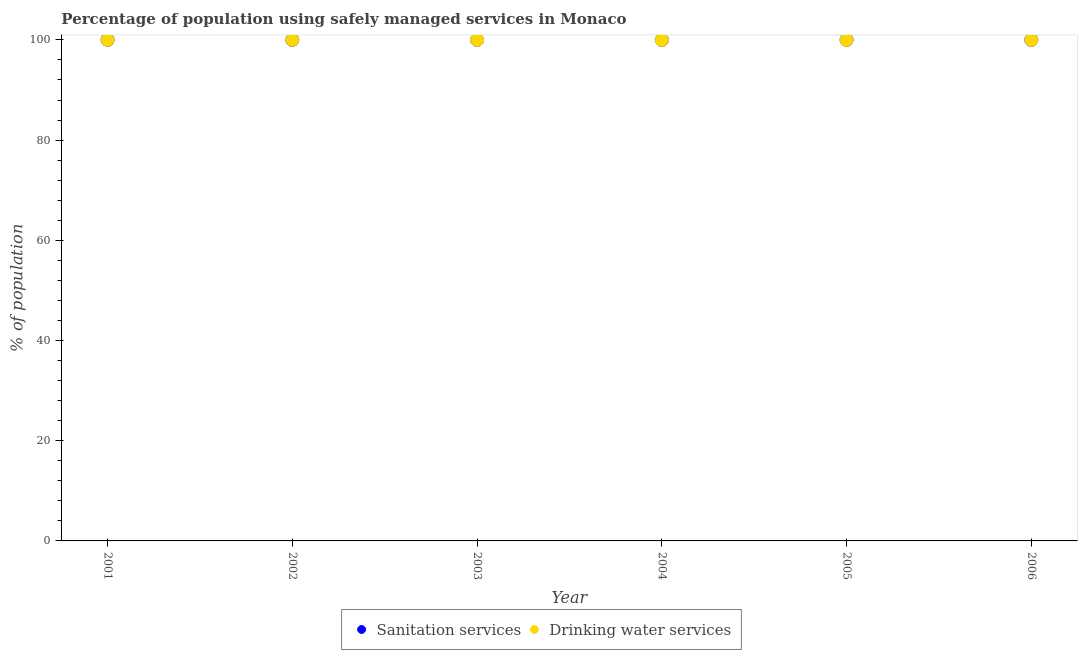How many different coloured dotlines are there?
Make the answer very short. 2. What is the percentage of population who used sanitation services in 2001?
Your answer should be very brief. 100. Across all years, what is the maximum percentage of population who used sanitation services?
Offer a very short reply. 100. Across all years, what is the minimum percentage of population who used sanitation services?
Keep it short and to the point. 100. In which year was the percentage of population who used drinking water services minimum?
Ensure brevity in your answer.  2001. What is the total percentage of population who used sanitation services in the graph?
Your answer should be compact. 600. What is the difference between the percentage of population who used sanitation services in 2001 and that in 2003?
Offer a terse response. 0. What is the average percentage of population who used sanitation services per year?
Give a very brief answer. 100. In how many years, is the percentage of population who used drinking water services greater than 12 %?
Give a very brief answer. 6. What is the ratio of the percentage of population who used sanitation services in 2002 to that in 2003?
Ensure brevity in your answer.  1. Is the percentage of population who used drinking water services in 2003 less than that in 2004?
Your answer should be compact. No. What is the difference between the highest and the lowest percentage of population who used sanitation services?
Your answer should be very brief. 0. Is the percentage of population who used sanitation services strictly greater than the percentage of population who used drinking water services over the years?
Provide a succinct answer. No. Is the percentage of population who used sanitation services strictly less than the percentage of population who used drinking water services over the years?
Offer a terse response. No. Are the values on the major ticks of Y-axis written in scientific E-notation?
Ensure brevity in your answer.  No. Does the graph contain any zero values?
Your answer should be very brief. No. Does the graph contain grids?
Your response must be concise. No. How many legend labels are there?
Provide a succinct answer. 2. How are the legend labels stacked?
Offer a terse response. Horizontal. What is the title of the graph?
Offer a terse response. Percentage of population using safely managed services in Monaco. What is the label or title of the X-axis?
Keep it short and to the point. Year. What is the label or title of the Y-axis?
Ensure brevity in your answer.  % of population. What is the % of population of Sanitation services in 2001?
Offer a terse response. 100. What is the % of population of Drinking water services in 2004?
Provide a succinct answer. 100. What is the % of population of Drinking water services in 2005?
Keep it short and to the point. 100. What is the % of population in Sanitation services in 2006?
Ensure brevity in your answer.  100. What is the % of population in Drinking water services in 2006?
Give a very brief answer. 100. What is the total % of population in Sanitation services in the graph?
Offer a very short reply. 600. What is the total % of population in Drinking water services in the graph?
Give a very brief answer. 600. What is the difference between the % of population of Sanitation services in 2001 and that in 2004?
Offer a terse response. 0. What is the difference between the % of population in Sanitation services in 2001 and that in 2005?
Provide a short and direct response. 0. What is the difference between the % of population in Sanitation services in 2001 and that in 2006?
Provide a short and direct response. 0. What is the difference between the % of population of Sanitation services in 2002 and that in 2003?
Offer a terse response. 0. What is the difference between the % of population in Sanitation services in 2002 and that in 2004?
Ensure brevity in your answer.  0. What is the difference between the % of population in Sanitation services in 2002 and that in 2005?
Provide a succinct answer. 0. What is the difference between the % of population of Drinking water services in 2002 and that in 2006?
Offer a terse response. 0. What is the difference between the % of population of Drinking water services in 2003 and that in 2004?
Keep it short and to the point. 0. What is the difference between the % of population in Drinking water services in 2003 and that in 2006?
Give a very brief answer. 0. What is the difference between the % of population in Sanitation services in 2004 and that in 2005?
Your answer should be very brief. 0. What is the difference between the % of population in Drinking water services in 2004 and that in 2005?
Keep it short and to the point. 0. What is the difference between the % of population of Drinking water services in 2004 and that in 2006?
Your response must be concise. 0. What is the difference between the % of population of Sanitation services in 2005 and that in 2006?
Offer a very short reply. 0. What is the difference between the % of population in Sanitation services in 2001 and the % of population in Drinking water services in 2003?
Keep it short and to the point. 0. What is the difference between the % of population of Sanitation services in 2002 and the % of population of Drinking water services in 2004?
Make the answer very short. 0. What is the difference between the % of population of Sanitation services in 2002 and the % of population of Drinking water services in 2005?
Keep it short and to the point. 0. What is the difference between the % of population in Sanitation services in 2002 and the % of population in Drinking water services in 2006?
Provide a succinct answer. 0. What is the difference between the % of population of Sanitation services in 2003 and the % of population of Drinking water services in 2004?
Your answer should be compact. 0. What is the difference between the % of population in Sanitation services in 2003 and the % of population in Drinking water services in 2006?
Give a very brief answer. 0. What is the difference between the % of population of Sanitation services in 2004 and the % of population of Drinking water services in 2005?
Your response must be concise. 0. What is the difference between the % of population of Sanitation services in 2005 and the % of population of Drinking water services in 2006?
Offer a very short reply. 0. What is the average % of population in Drinking water services per year?
Provide a succinct answer. 100. In the year 2001, what is the difference between the % of population in Sanitation services and % of population in Drinking water services?
Your answer should be compact. 0. In the year 2003, what is the difference between the % of population in Sanitation services and % of population in Drinking water services?
Provide a succinct answer. 0. What is the ratio of the % of population in Sanitation services in 2001 to that in 2002?
Ensure brevity in your answer.  1. What is the ratio of the % of population in Sanitation services in 2001 to that in 2003?
Give a very brief answer. 1. What is the ratio of the % of population of Drinking water services in 2001 to that in 2005?
Your response must be concise. 1. What is the ratio of the % of population in Sanitation services in 2001 to that in 2006?
Ensure brevity in your answer.  1. What is the ratio of the % of population of Drinking water services in 2001 to that in 2006?
Give a very brief answer. 1. What is the ratio of the % of population in Sanitation services in 2002 to that in 2004?
Your answer should be compact. 1. What is the ratio of the % of population in Drinking water services in 2002 to that in 2004?
Your answer should be very brief. 1. What is the ratio of the % of population of Drinking water services in 2002 to that in 2005?
Make the answer very short. 1. What is the ratio of the % of population in Sanitation services in 2003 to that in 2005?
Give a very brief answer. 1. What is the ratio of the % of population in Drinking water services in 2003 to that in 2005?
Make the answer very short. 1. What is the ratio of the % of population in Drinking water services in 2003 to that in 2006?
Make the answer very short. 1. What is the ratio of the % of population of Sanitation services in 2004 to that in 2005?
Offer a terse response. 1. What is the ratio of the % of population in Sanitation services in 2005 to that in 2006?
Ensure brevity in your answer.  1. What is the difference between the highest and the lowest % of population in Sanitation services?
Offer a very short reply. 0. What is the difference between the highest and the lowest % of population in Drinking water services?
Provide a short and direct response. 0. 